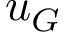Convert formula to latex. <formula><loc_0><loc_0><loc_500><loc_500>u _ { G }</formula> 